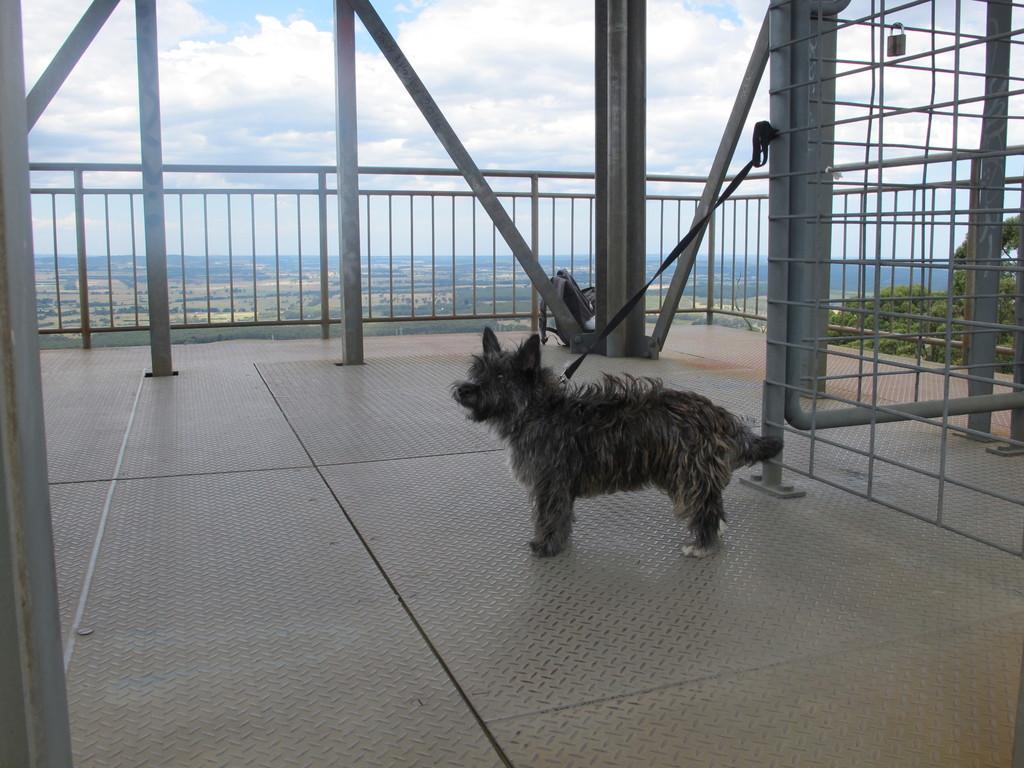In one or two sentences, can you explain what this image depicts? In this image I can see a dog is tied to an object. In the background I can see fence, poles, trees and the sky. 